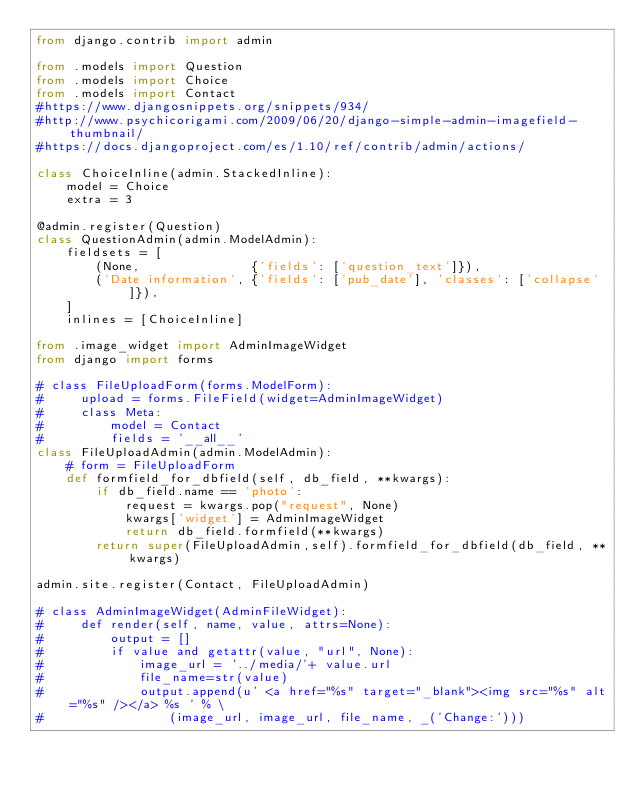Convert code to text. <code><loc_0><loc_0><loc_500><loc_500><_Python_>from django.contrib import admin

from .models import Question
from .models import Choice
from .models import Contact
#https://www.djangosnippets.org/snippets/934/
#http://www.psychicorigami.com/2009/06/20/django-simple-admin-imagefield-thumbnail/
#https://docs.djangoproject.com/es/1.10/ref/contrib/admin/actions/

class ChoiceInline(admin.StackedInline):
    model = Choice
    extra = 3

@admin.register(Question)
class QuestionAdmin(admin.ModelAdmin):
    fieldsets = [
        (None,               {'fields': ['question_text']}),
        ('Date information', {'fields': ['pub_date'], 'classes': ['collapse']}),
    ]
    inlines = [ChoiceInline]

from .image_widget import AdminImageWidget
from django import forms

# class FileUploadForm(forms.ModelForm):
#     upload = forms.FileField(widget=AdminImageWidget)
#     class Meta:
#         model = Contact
#         fields = '__all__'
class FileUploadAdmin(admin.ModelAdmin):
    # form = FileUploadForm
    def formfield_for_dbfield(self, db_field, **kwargs):
        if db_field.name == 'photo':
            request = kwargs.pop("request", None)
            kwargs['widget'] = AdminImageWidget
            return db_field.formfield(**kwargs)
        return super(FileUploadAdmin,self).formfield_for_dbfield(db_field, **kwargs)

admin.site.register(Contact, FileUploadAdmin)

# class AdminImageWidget(AdminFileWidget):
#     def render(self, name, value, attrs=None):
#         output = []
#         if value and getattr(value, "url", None):
#             image_url = '../media/'+ value.url
#             file_name=str(value)
#             output.append(u' <a href="%s" target="_blank"><img src="%s" alt="%s" /></a> %s ' % \
#                 (image_url, image_url, file_name, _('Change:')))</code> 